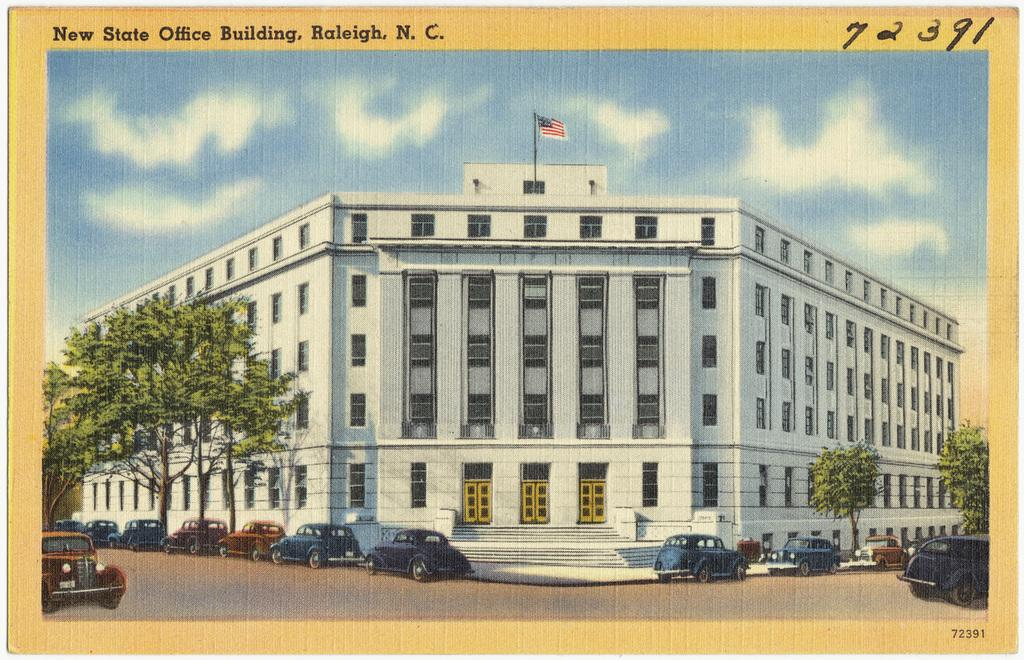What type of vehicles can be seen on the road in the image? There are cars on the road in the image. What natural elements are present in the image? There are trees in the image. Can you describe the structure in the image? There is a building with windows and doors in the image. What architectural feature is visible in the image? There are steps in the image. What symbol can be seen in the image? There is a flag in the image. What can be seen in the background of the image? The sky with clouds is visible in the background of the image. How many chairs are placed around the governor in the image? There is no governor or chairs present in the image. What type of cart is being pulled by the horse in the image? There is no horse or cart present in the image. 